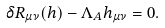<formula> <loc_0><loc_0><loc_500><loc_500>\delta R _ { \mu \nu } ( h ) - \Lambda _ { A } h _ { \mu \nu } = 0 .</formula> 